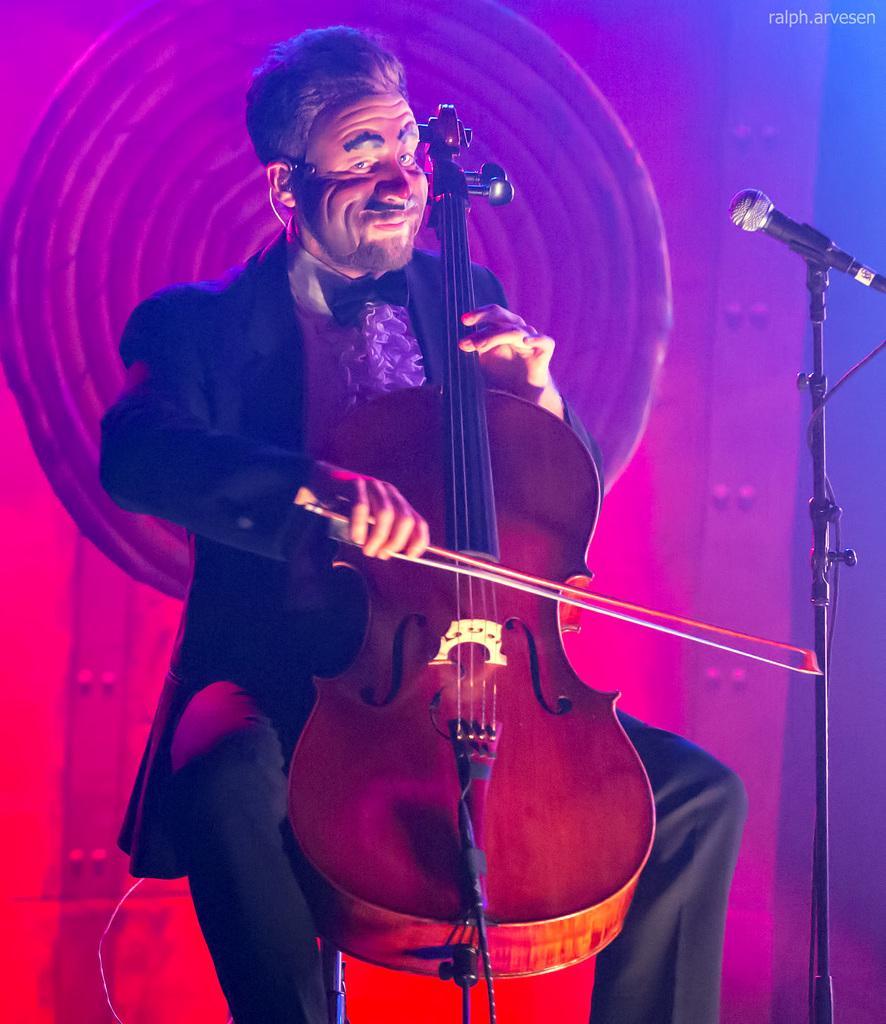Please provide a concise description of this image. In this image, we can see a person wearing clothes and playing musical instrument. There is a mic on the right side of the image. 